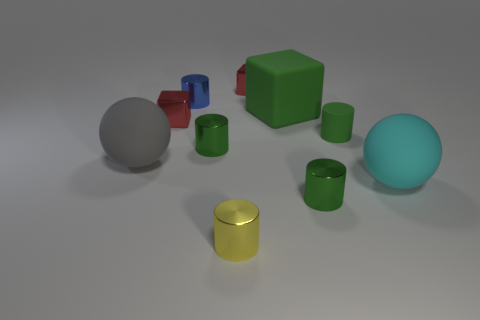What number of tiny matte spheres have the same color as the rubber cube?
Your answer should be compact. 0. There is a block that is behind the large rubber cube; is its color the same as the big rubber block?
Provide a short and direct response. No. What shape is the large thing behind the gray sphere?
Offer a very short reply. Cube. Are there any small rubber cylinders left of the small green metallic cylinder that is in front of the big gray sphere?
Provide a short and direct response. No. What number of tiny blue objects have the same material as the cyan thing?
Offer a terse response. 0. There is a green metal thing that is in front of the green shiny cylinder on the left side of the small green object in front of the large gray thing; what is its size?
Provide a short and direct response. Small. What number of large rubber blocks are in front of the yellow cylinder?
Ensure brevity in your answer.  0. Is the number of tiny green things greater than the number of tiny blue matte things?
Keep it short and to the point. Yes. What is the size of the rubber object that is the same color as the big rubber block?
Offer a very short reply. Small. There is a green cylinder that is both on the right side of the yellow shiny cylinder and left of the green matte cylinder; what is its size?
Give a very brief answer. Small. 